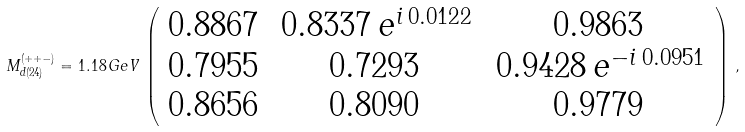<formula> <loc_0><loc_0><loc_500><loc_500>M _ { d ( 2 4 ) } ^ { ( + + - ) } = 1 . 1 8 \, G e V \, \left ( \begin{array} { c c c } 0 . 8 8 6 7 & \, 0 . 8 3 3 7 \, e ^ { i \, 0 . 0 1 2 2 } & 0 . 9 8 6 3 \\ 0 . 7 9 5 5 & 0 . 7 2 9 3 & \, 0 . 9 4 2 8 \, e ^ { - i \, 0 . 0 9 5 1 } \\ 0 . 8 6 5 6 & 0 . 8 0 9 0 & 0 . 9 7 7 9 \end{array} \right ) \, ,</formula> 